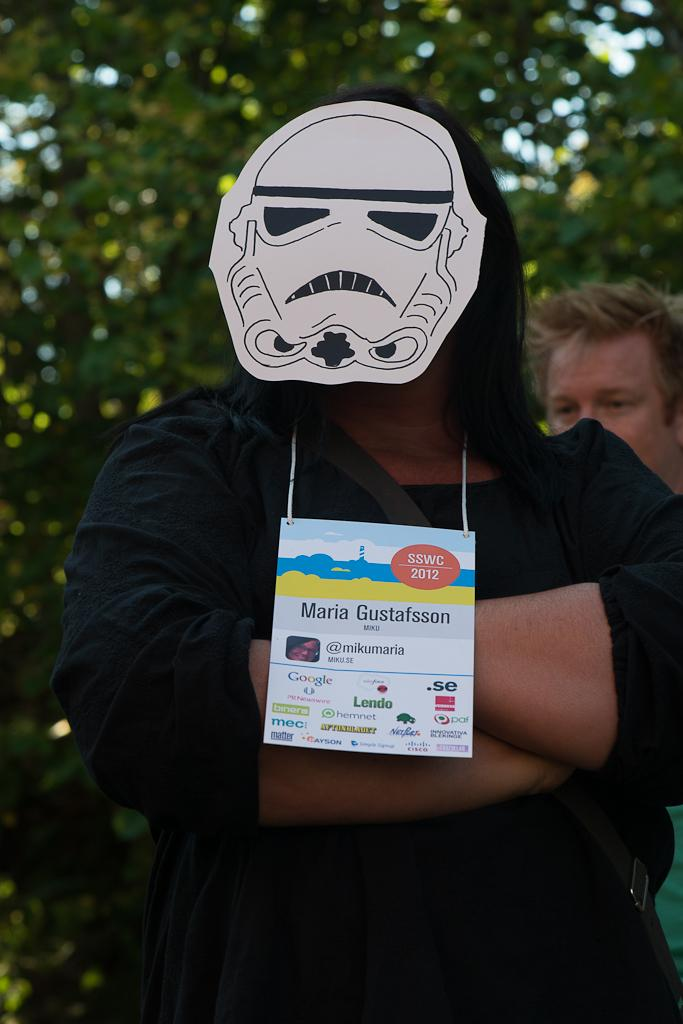What is the person in the image wearing? The person in the image is wearing a black dress. What is the person wearing on their face? The person is wearing a face mask. What is hanging around the person's neck? There is a tag around the person's neck. Can you describe the background of the image? There is another person in the background of the image, and trees are visible as well. What type of amusement park can be seen in the background of the image? There is no amusement park visible in the background of the image; it features another person and trees. What industry is represented by the person in the image? The image does not depict any specific industry; it simply shows a person wearing a black dress, a face mask, and a tag around their neck. 